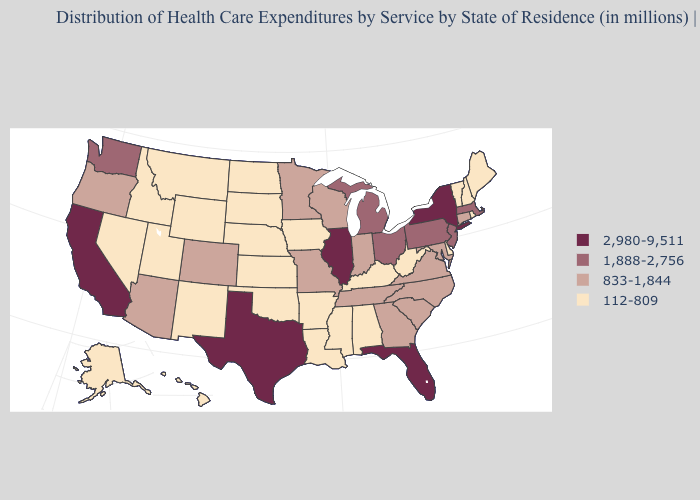Is the legend a continuous bar?
Short answer required. No. Name the states that have a value in the range 2,980-9,511?
Answer briefly. California, Florida, Illinois, New York, Texas. What is the value of Missouri?
Give a very brief answer. 833-1,844. Does Illinois have the lowest value in the MidWest?
Keep it brief. No. What is the value of New York?
Concise answer only. 2,980-9,511. Does Virginia have a higher value than New Hampshire?
Keep it brief. Yes. What is the value of Maryland?
Concise answer only. 833-1,844. Name the states that have a value in the range 2,980-9,511?
Quick response, please. California, Florida, Illinois, New York, Texas. Does Kentucky have the lowest value in the South?
Write a very short answer. Yes. What is the highest value in states that border Rhode Island?
Short answer required. 1,888-2,756. Does Michigan have the highest value in the USA?
Concise answer only. No. Does the map have missing data?
Be succinct. No. Does the first symbol in the legend represent the smallest category?
Write a very short answer. No. Is the legend a continuous bar?
Give a very brief answer. No. What is the value of Missouri?
Be succinct. 833-1,844. 